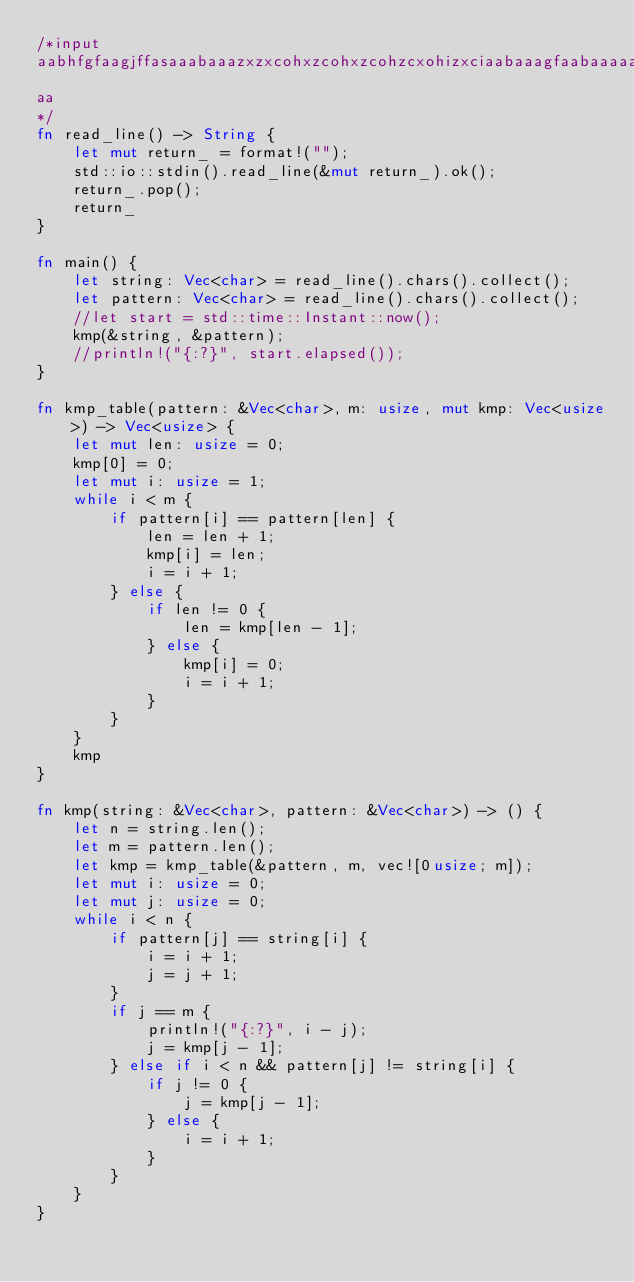Convert code to text. <code><loc_0><loc_0><loc_500><loc_500><_Rust_>/*input
aabhfgfaagjffasaaabaaazxzxcohxzcohxzcohzcxohizxciaabaaagfaabaaaaasfdasfabaaaaabaaafgsdffdhaabaagffgffhdfaaabaghfdaa
aa
*/
fn read_line() -> String {
    let mut return_ = format!("");
    std::io::stdin().read_line(&mut return_).ok();
    return_.pop();
    return_
}

fn main() {
    let string: Vec<char> = read_line().chars().collect();
    let pattern: Vec<char> = read_line().chars().collect();
    //let start = std::time::Instant::now();
    kmp(&string, &pattern);
    //println!("{:?}", start.elapsed());
}

fn kmp_table(pattern: &Vec<char>, m: usize, mut kmp: Vec<usize>) -> Vec<usize> {
    let mut len: usize = 0;
    kmp[0] = 0;
    let mut i: usize = 1;
    while i < m {
        if pattern[i] == pattern[len] {
            len = len + 1;
            kmp[i] = len;
            i = i + 1;
        } else {
            if len != 0 {
                len = kmp[len - 1];
            } else {
                kmp[i] = 0;
                i = i + 1;
            }
        }
    }
    kmp
}

fn kmp(string: &Vec<char>, pattern: &Vec<char>) -> () {
    let n = string.len();
    let m = pattern.len();
    let kmp = kmp_table(&pattern, m, vec![0usize; m]);
    let mut i: usize = 0;
    let mut j: usize = 0;
    while i < n {
        if pattern[j] == string[i] {
            i = i + 1;
            j = j + 1;
        }
        if j == m {
            println!("{:?}", i - j);
            j = kmp[j - 1];
        } else if i < n && pattern[j] != string[i] {
            if j != 0 {
                j = kmp[j - 1];
            } else {
                i = i + 1;
            }
        }
    }
}

</code> 